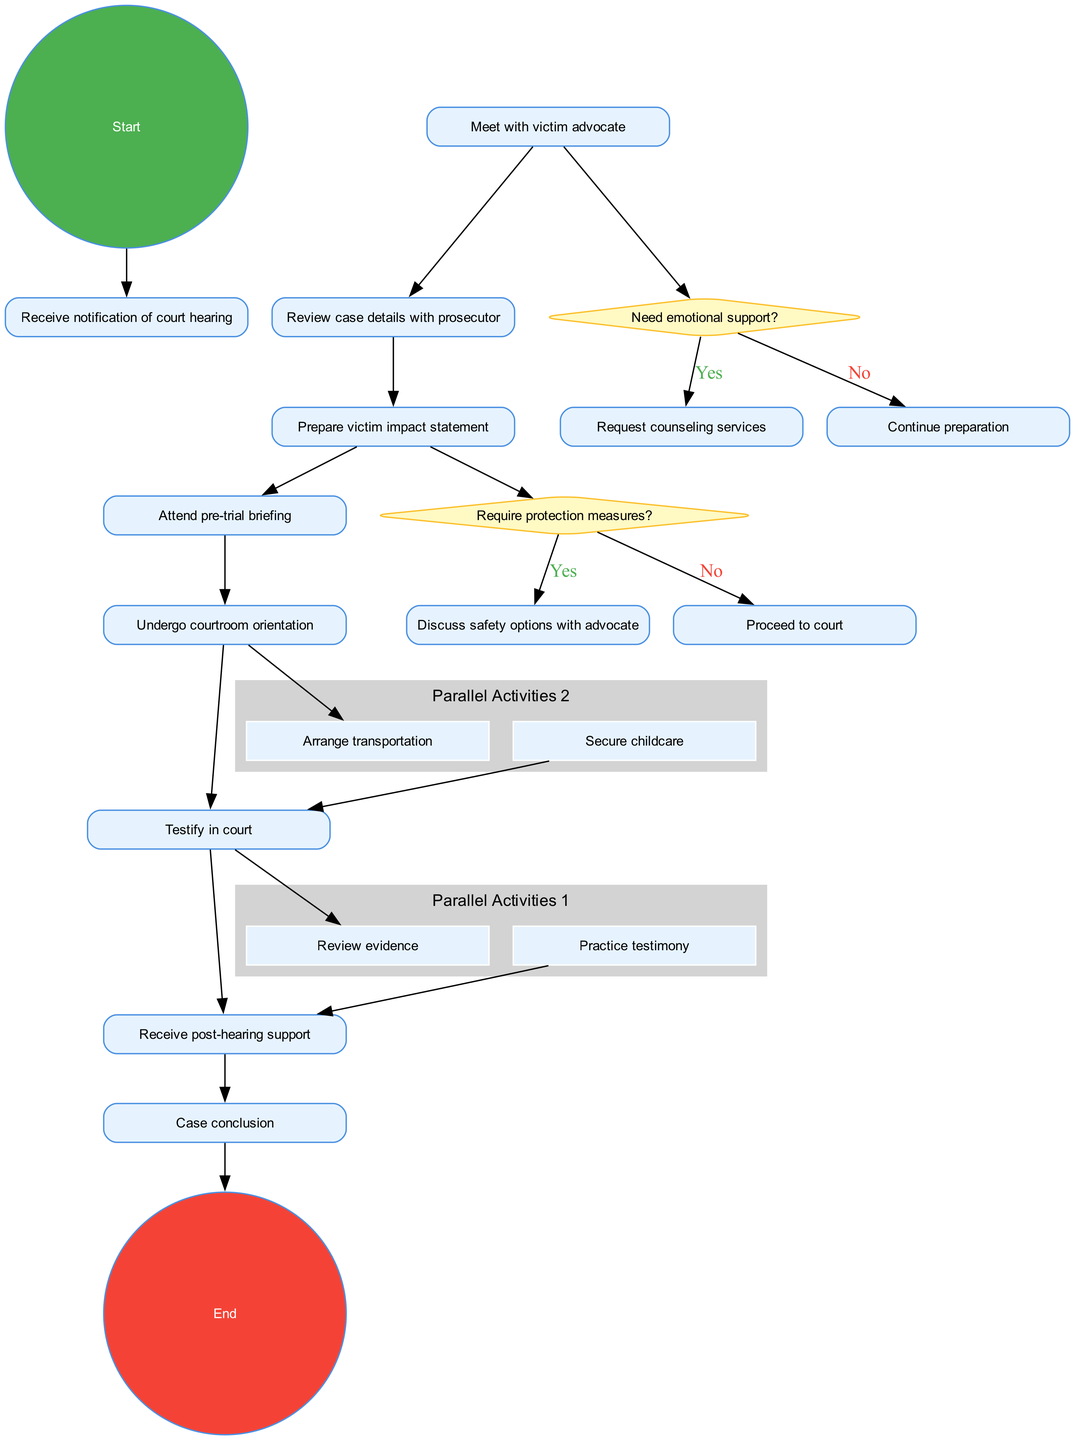What is the initial node in the diagram? The initial node is indicated as the starting point of the activity, which is "Receive notification of court hearing."
Answer: Receive notification of court hearing How many activities are there before the final node? By counting the specific activity nodes listed, there are a total of seven activities outlined in the diagram before reaching the final conclusion.
Answer: 7 What question is asked regarding emotional support? The decision point related to emotional support asks, "Need emotional support?" to determine if the victim requires additional help.
Answer: Need emotional support? What comes after preparing the victim impact statement? The activity that follows "Prepare victim impact statement" is "Attend pre-trial briefing," which leads to the next step in the process.
Answer: Attend pre-trial briefing What are two activities that occur in parallel? The diagram shows that "Review evidence" and "Practice testimony" are two activities that occur concurrently as part of the preparation process.
Answer: Review evidence, Practice testimony If the victim needs protection measures, what action follows? If the victim decides they need protection measures, the following action is to "Discuss safety options with advocate," which is a crucial step for their security.
Answer: Discuss safety options with advocate How many decision nodes are in the diagram? There are two decision nodes indicated in the diagram, each prompting a question related to the victim's preparation process.
Answer: 2 What is the last activity before the case conclusion? The final activity before reaching the case conclusion is "Receive post-hearing support," which signifies the wrap-up after the hearing.
Answer: Receive post-hearing support 